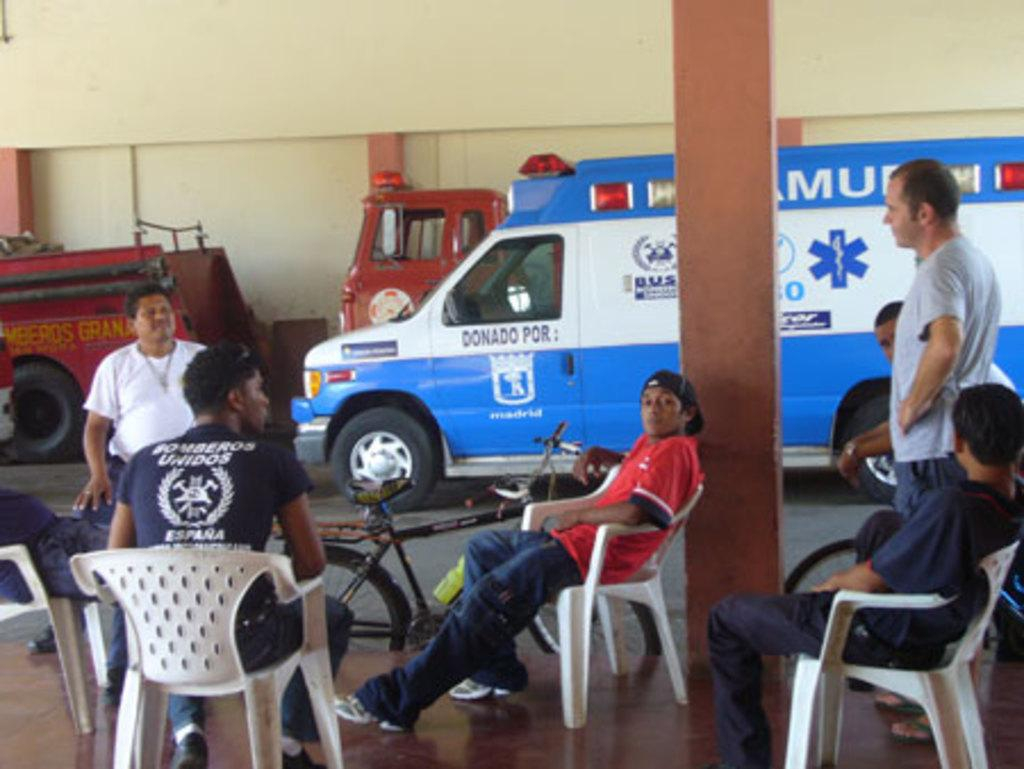What are the people in the image doing? The people in the image are sitting on chairs. What type of vehicles can be seen in the image? There are vehicle vans in the image. What is the purpose of the parked vehicle in the image? An ambulance is parked on the road in the image. What type of seed is being planted by the people sitting on chairs in the image? There is no seed or planting activity depicted in the image. How many knees are visible in the image? The number of knees visible in the image cannot be determined from the provided facts, as the focus is on the people sitting on chairs, not their knees. 